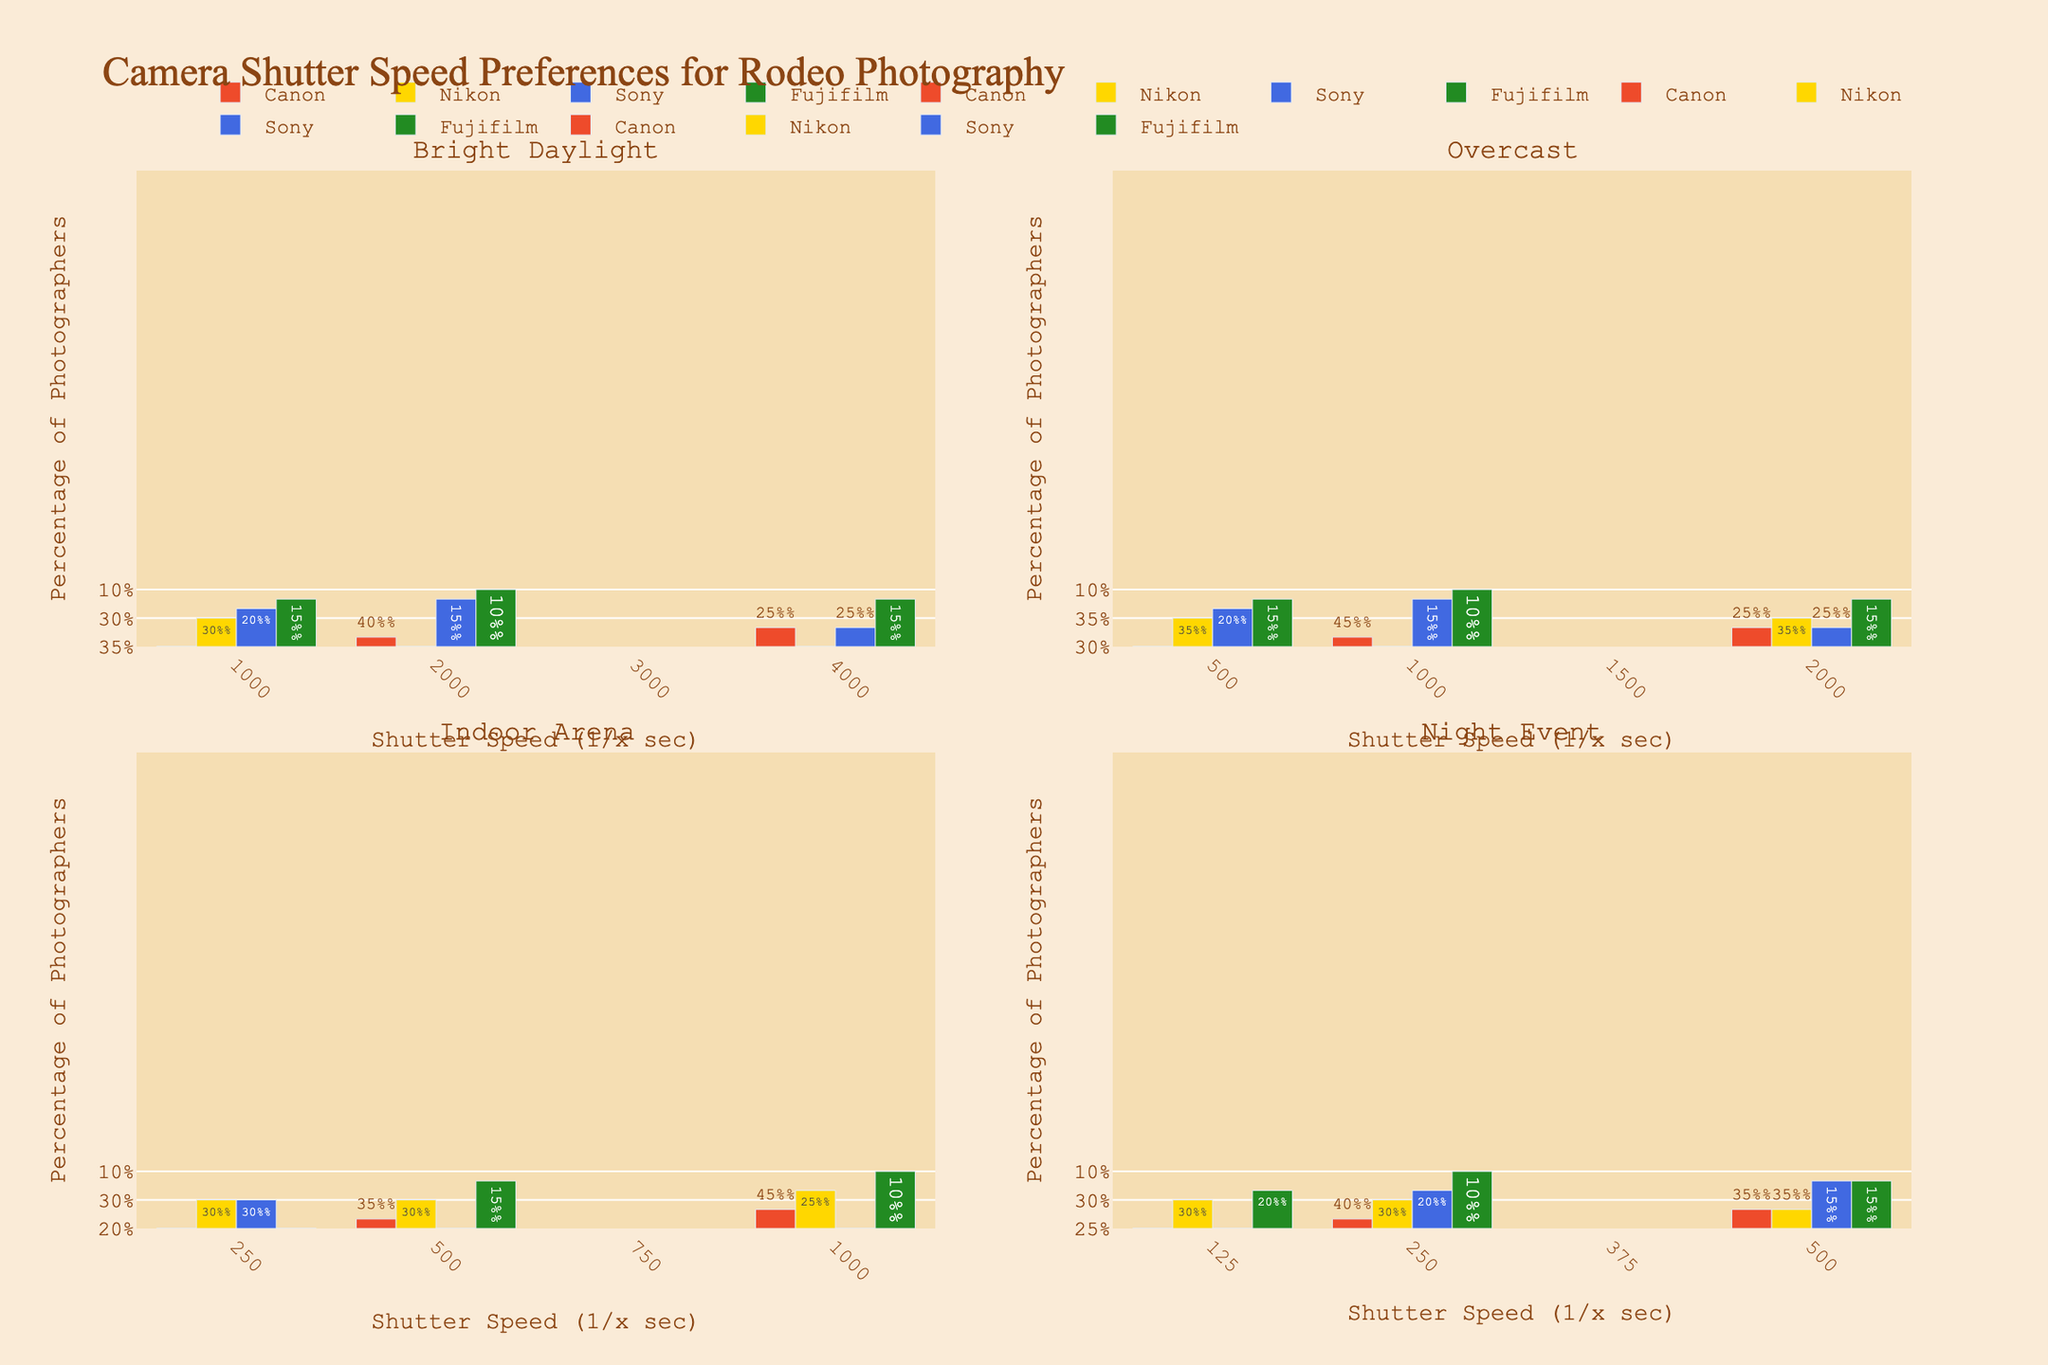What's the title of the figure? The title can be found at the top of the figure. It summarizes the overall content of the figure.
Answer: Camera Shutter Speed Preferences for Rodeo Photography What are the four lighting conditions represented in the subplots? The subplot titles indicate the different lighting conditions. There are four unique conditions shown.
Answer: Bright Daylight, Overcast, Indoor Arena, Night Event Which camera brand has the highest percentage of photographers using a shutter speed of 1000 in Bright Daylight? Look at the Bright Daylight subplot and identify the bar representing 1000 shutter speed and the highest percentage for any brand.
Answer: Canon For Indoor Arena lighting, which shutter speed is preferred by most Sony photographers? In the Indoor Arena subplot, identify the bars for Sony to see which shutter speed has the highest percentage.
Answer: 250 In Overcast conditions, is the shutter speed of 1000 more popular than 2000 for Canon photographers? Compare the heights of the Canon bars for shutter speeds of 1000 and 2000 in the Overcast subplot.
Answer: Yes What is the least preferred shutter speed among Nikon photographers during Night Events? Look at the Night Event subplot and identify which Nikon bar has the lowest percentage.
Answer: 500 Between Fujifilm photographers shooting in Bright Daylight and Indoor Arena, which condition shows a higher preference for a shutter speed of 500? Compare the percentage bars for Fujifilm at 500 shutter speed in both Bright Daylight and Indoor Arena subplots.
Answer: Indoor Arena For which lighting condition do we see the most even distribution of preferences among all shutter speeds for Nikon photographers? Analyze the height of the Nikon bars across all shutter speeds in each subplot to see where they are most evenly distributed.
Answer: Night Event Which lighting condition shows the highest aggregate percentage for Canon photographers using shutter speeds of 500 or lower? (Consider all speeds ≤ 500) Sum up the percentages for Canon photographers using shutter speeds of 500 or lower for each lighting condition and compare the totals.
Answer: Indoor Arena 